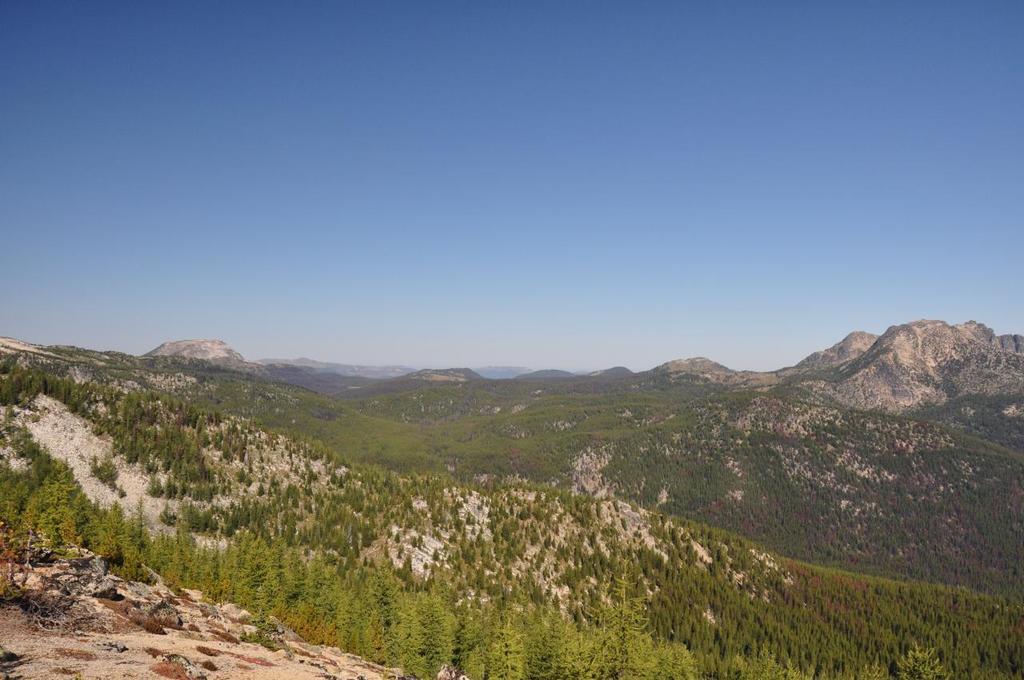Please provide a concise description of this image. In this image we can see ground, trees, and hills. In the background there is sky. 